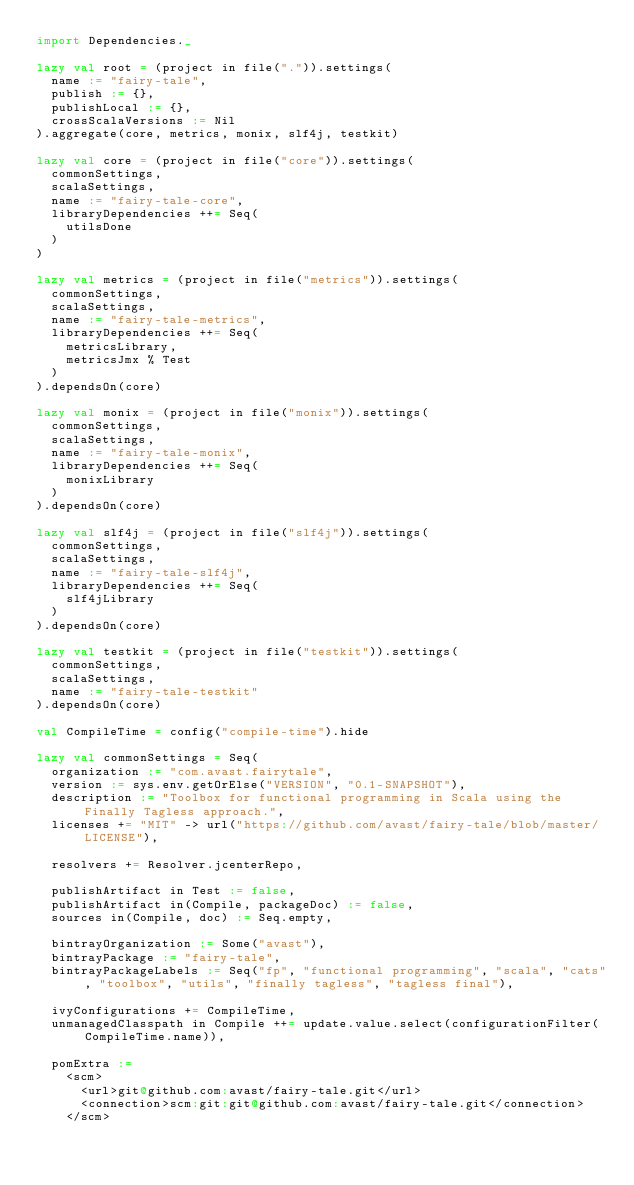Convert code to text. <code><loc_0><loc_0><loc_500><loc_500><_Scala_>import Dependencies._

lazy val root = (project in file(".")).settings(
  name := "fairy-tale",
  publish := {},
  publishLocal := {},
  crossScalaVersions := Nil
).aggregate(core, metrics, monix, slf4j, testkit)

lazy val core = (project in file("core")).settings(
  commonSettings,
  scalaSettings,
  name := "fairy-tale-core",
  libraryDependencies ++= Seq(
    utilsDone
  )
)

lazy val metrics = (project in file("metrics")).settings(
  commonSettings,
  scalaSettings,
  name := "fairy-tale-metrics",
  libraryDependencies ++= Seq(
    metricsLibrary,
    metricsJmx % Test
  )
).dependsOn(core)

lazy val monix = (project in file("monix")).settings(
  commonSettings,
  scalaSettings,
  name := "fairy-tale-monix",
  libraryDependencies ++= Seq(
    monixLibrary
  )
).dependsOn(core)

lazy val slf4j = (project in file("slf4j")).settings(
  commonSettings,
  scalaSettings,
  name := "fairy-tale-slf4j",
  libraryDependencies ++= Seq(
    slf4jLibrary
  )
).dependsOn(core)

lazy val testkit = (project in file("testkit")).settings(
  commonSettings,
  scalaSettings,
  name := "fairy-tale-testkit"
).dependsOn(core)

val CompileTime = config("compile-time").hide

lazy val commonSettings = Seq(
  organization := "com.avast.fairytale",
  version := sys.env.getOrElse("VERSION", "0.1-SNAPSHOT"),
  description := "Toolbox for functional programming in Scala using the Finally Tagless approach.",
  licenses += "MIT" -> url("https://github.com/avast/fairy-tale/blob/master/LICENSE"),

  resolvers += Resolver.jcenterRepo,

  publishArtifact in Test := false,
  publishArtifact in(Compile, packageDoc) := false,
  sources in(Compile, doc) := Seq.empty,

  bintrayOrganization := Some("avast"),
  bintrayPackage := "fairy-tale",
  bintrayPackageLabels := Seq("fp", "functional programming", "scala", "cats", "toolbox", "utils", "finally tagless", "tagless final"),

  ivyConfigurations += CompileTime,
  unmanagedClasspath in Compile ++= update.value.select(configurationFilter(CompileTime.name)),

  pomExtra :=
    <scm>
      <url>git@github.com:avast/fairy-tale.git</url>
      <connection>scm:git:git@github.com:avast/fairy-tale.git</connection>
    </scm></code> 